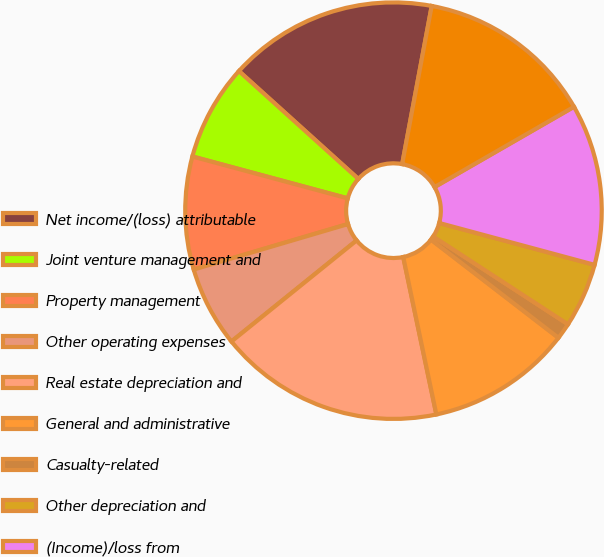Convert chart. <chart><loc_0><loc_0><loc_500><loc_500><pie_chart><fcel>Net income/(loss) attributable<fcel>Joint venture management and<fcel>Property management<fcel>Other operating expenses<fcel>Real estate depreciation and<fcel>General and administrative<fcel>Casualty-related<fcel>Other depreciation and<fcel>(Income)/loss from<fcel>Interest expense<nl><fcel>16.25%<fcel>7.5%<fcel>8.75%<fcel>6.25%<fcel>17.49%<fcel>11.25%<fcel>1.26%<fcel>5.0%<fcel>12.5%<fcel>13.75%<nl></chart> 